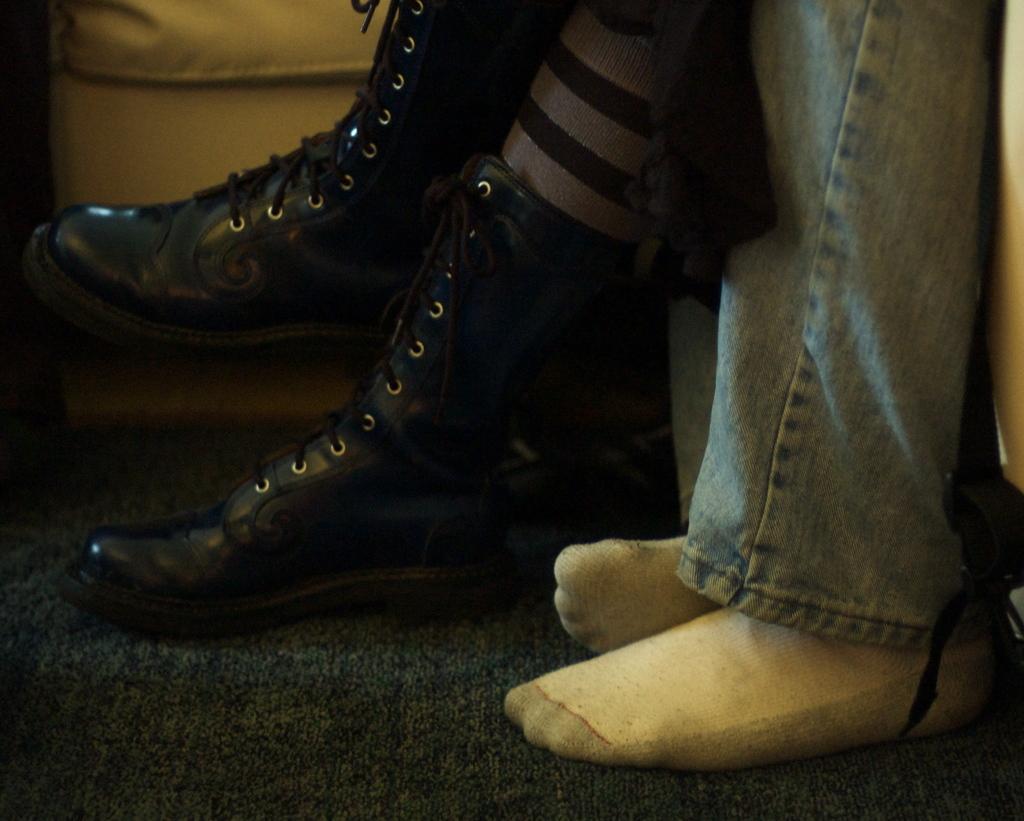Please provide a concise description of this image. In this picture we can see legs of two persons, and a person wore shoes, at the bottom we can find a mat. 